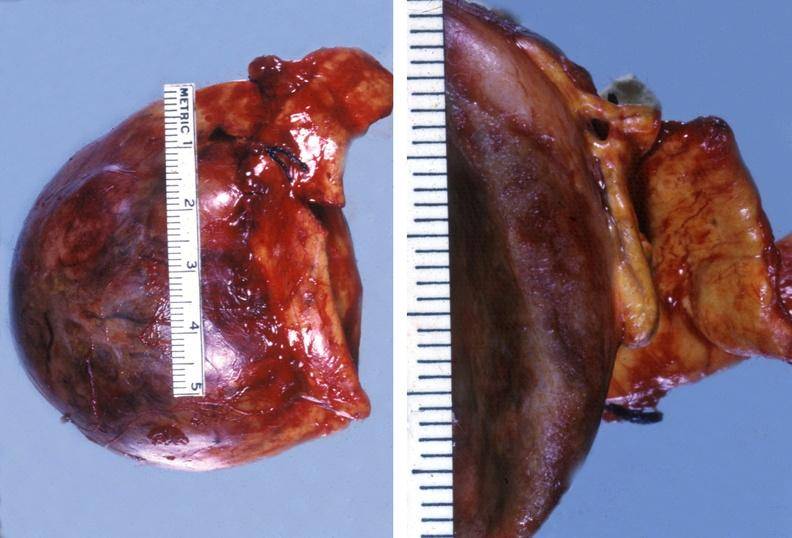what does this image show?
Answer the question using a single word or phrase. Adrenal phaeochromocytoma 